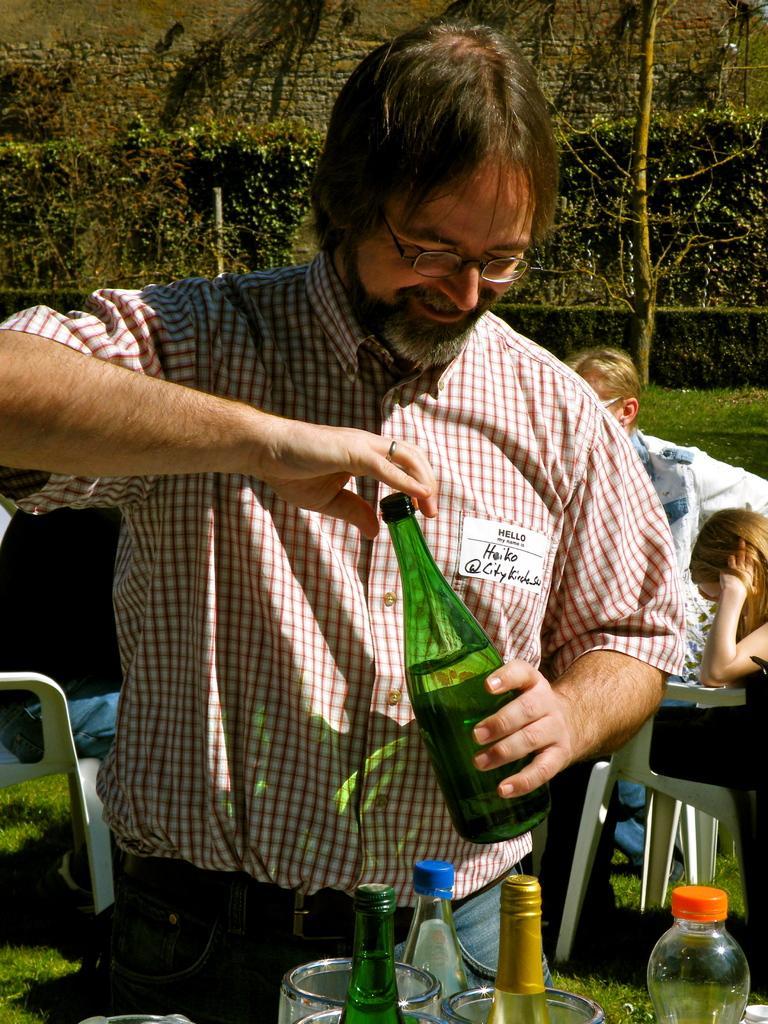Please provide a concise description of this image. In this image the man is holding the bottle. There are chairs in the garden. At the back side there are trees. 